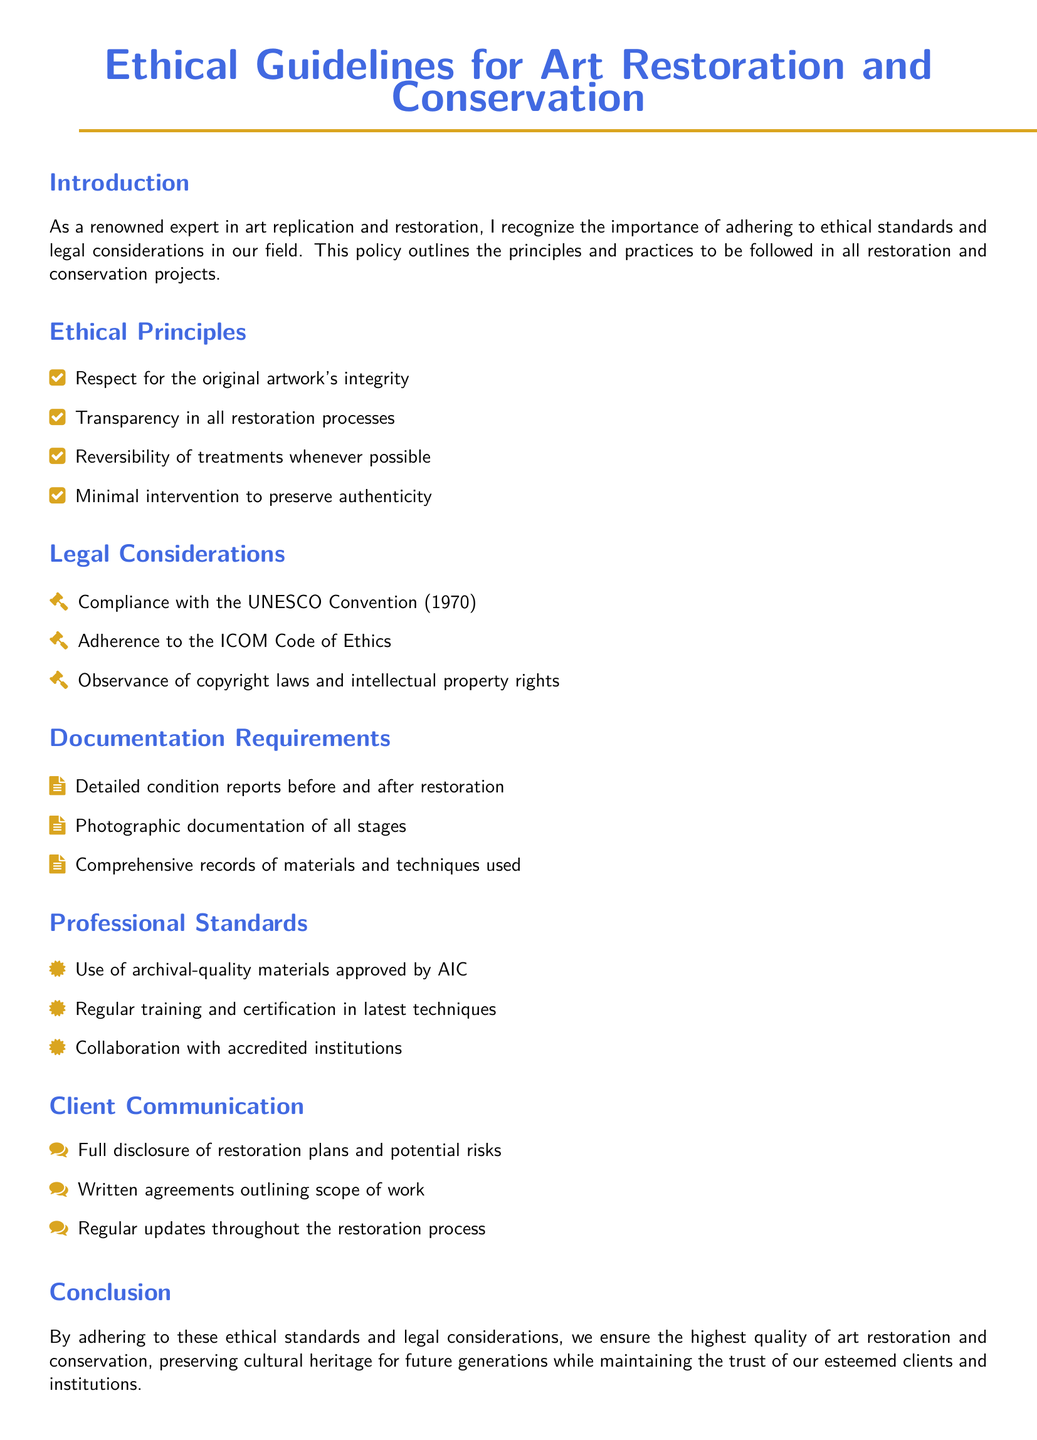What is the title of the document? The title is explicitly mentioned at the beginning of the document, which is Ethical Guidelines for Art Restoration and Conservation.
Answer: Ethical Guidelines for Art Restoration and Conservation How many ethical principles are listed? The number of ethical principles can be counted from the section titled Ethical Principles, which lists four principles.
Answer: Four What is one legal consideration mentioned? One of the legal considerations is stated under the section titled Legal Considerations, specifically the compliance with the UNESCO Convention.
Answer: Compliance with the UNESCO Convention What type of materials are recommended according to the professional standards? The professional standards section specifies the use of archival-quality materials approved by AIC.
Answer: Archival-quality materials What documentation is required before and after restoration? The section on Documentation Requirements states the need for detailed condition reports before and after restoration.
Answer: Detailed condition reports What is a principle that emphasizes a non-invasive approach? The ethical principles mention minimal intervention to preserve authenticity as a guiding principle.
Answer: Minimal intervention How often should professionals receive training and certification? The standards mention regular training as a requisite, implying an ongoing obligation, but does not specify a frequency.
Answer: Regularly What is required during client communication regarding restoration plans? The document specifies the need for full disclosure of restoration plans and potential risks under the Client Communication section.
Answer: Full disclosure What is the significance of documenting materials and techniques used? The documentation is crucial for transparency and accountability, as stated under the Documentation Requirements heading.
Answer: Transparency and accountability 